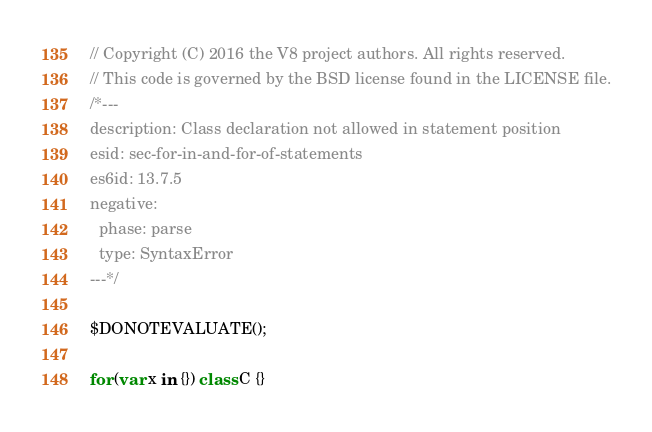Convert code to text. <code><loc_0><loc_0><loc_500><loc_500><_JavaScript_>// Copyright (C) 2016 the V8 project authors. All rights reserved.
// This code is governed by the BSD license found in the LICENSE file.
/*---
description: Class declaration not allowed in statement position
esid: sec-for-in-and-for-of-statements
es6id: 13.7.5
negative:
  phase: parse
  type: SyntaxError
---*/

$DONOTEVALUATE();

for (var x in {}) class C {}
</code> 